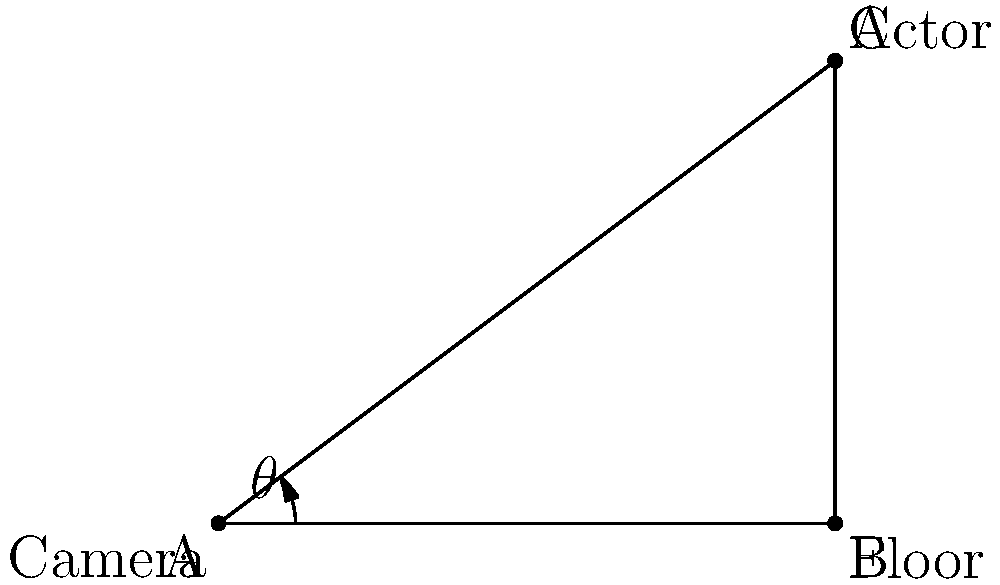In a crucial scene of your breakthrough role, the director wants to create a dramatic effect by shooting from a low angle. If the camera is positioned on the floor 4 meters away from you, and you're standing 3 meters tall, what is the angle $\theta$ (in degrees) between the floor and the camera's line of sight? To solve this problem, we can use trigonometry:

1. The scene forms a right-angled triangle, where:
   - The floor is the base (adjacent to the angle we're looking for)
   - Your height is the opposite side
   - The camera's line of sight is the hypotenuse

2. We can use the tangent function to find the angle:

   $\tan(\theta) = \frac{\text{opposite}}{\text{adjacent}} = \frac{\text{your height}}{\text{distance on floor}}$

3. Plugging in the values:

   $\tan(\theta) = \frac{3}{4}$

4. To find $\theta$, we need to use the inverse tangent (arctan or $\tan^{-1}$):

   $\theta = \tan^{-1}(\frac{3}{4})$

5. Using a calculator or computer:

   $\theta \approx 36.87°$

This angle creates a low-angle shot, which can make the subject (you, the actor) appear more powerful or imposing, adding to the dramatic effect the director wants to achieve.
Answer: 36.87° 